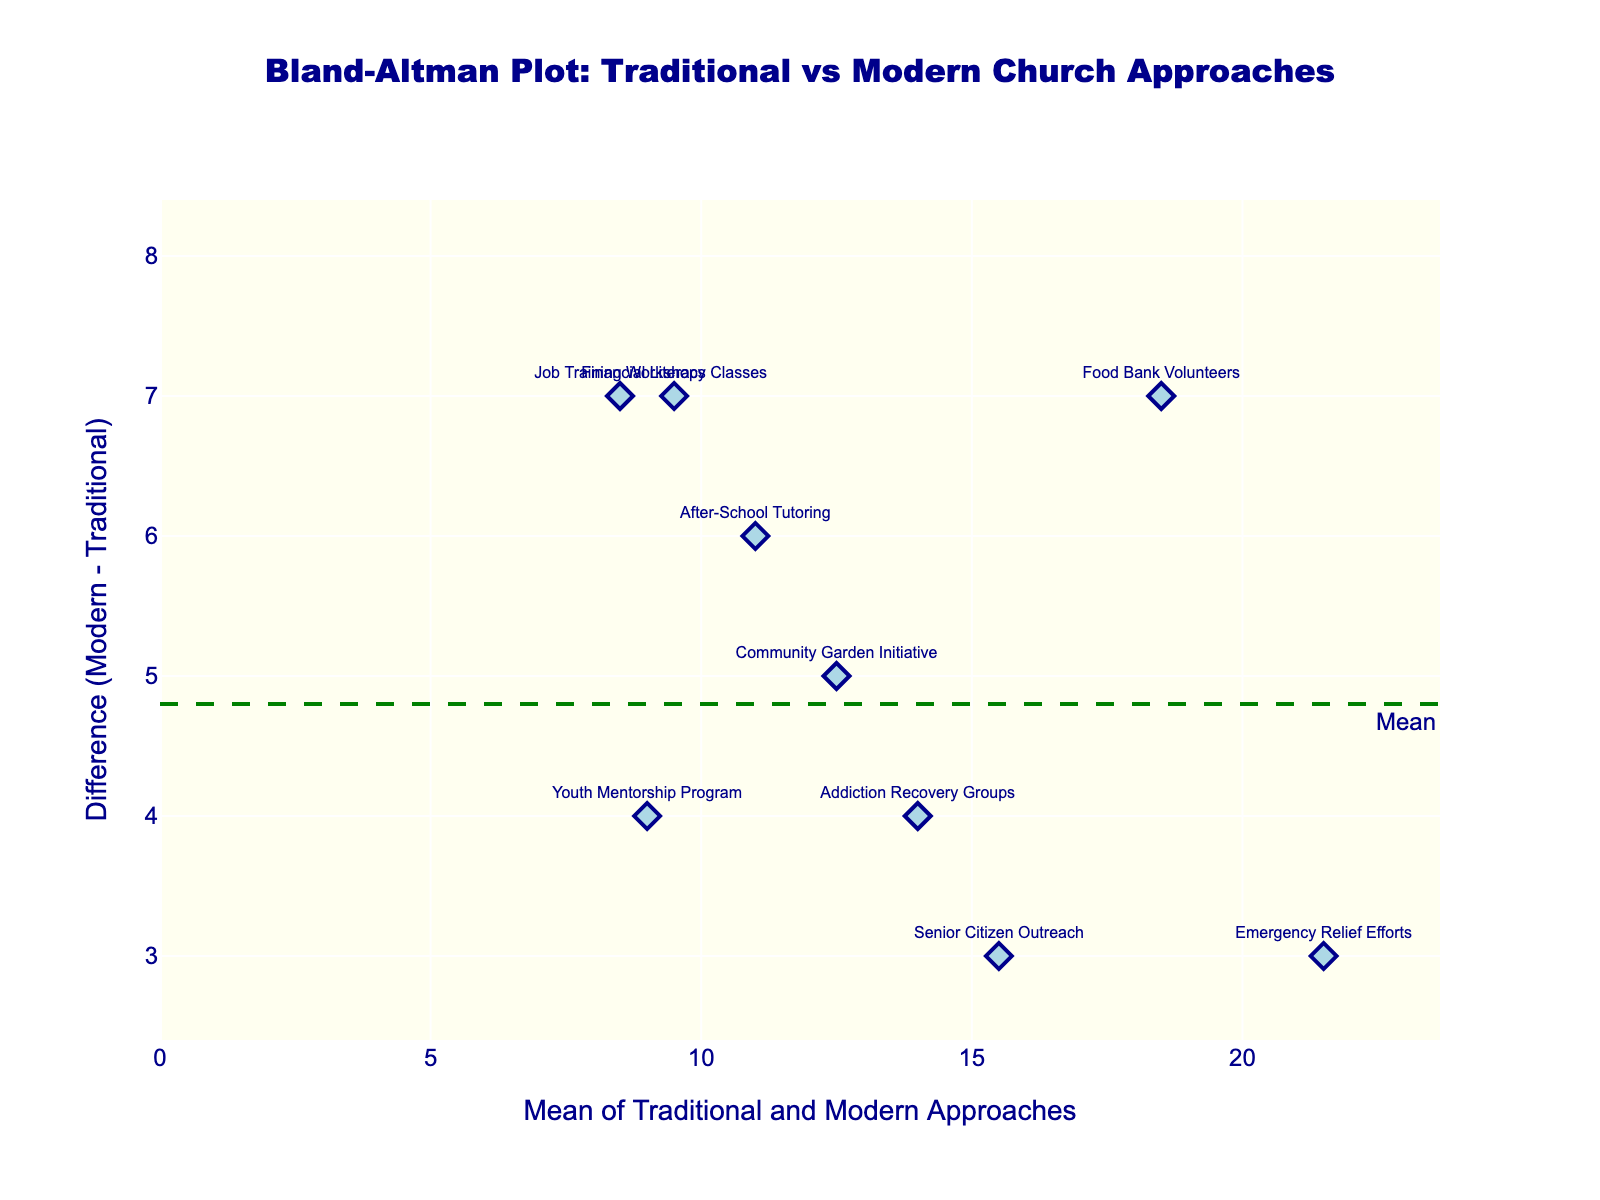Which method had the highest mean value of Traditional and Modern approaches? By looking at the plot and the x-axis (which shows the mean value), the data point with the highest position on the x-axis represents the method with the highest mean value. Here, "Emergency Relief Efforts" has the highest mean value.
Answer: Emergency Relief Efforts What is the mean difference between the Modern and Traditional approaches? The mean difference is represented by a horizontal dashed line on the plot. The green dashed line labeled "Mean" indicates this value.
Answer: About 4.5 What is the difference in impact on local poverty rates for Job Training Workshops between the Traditional and Modern approaches? Locate the "Job Training Workshops" data point on the plot by its label. The y-axis value for this point represents the difference between the Modern and Traditional approaches.
Answer: 7 Which method had the smallest impact difference between the Modern and Traditional approaches? The smallest impact difference corresponds to the data point closest to the x-axis (difference 0). "Homeless Shelter Support" is the closest to zero on the y-axis.
Answer: Homeless Shelter Support How does the variation of differences (spread) compare around the mean difference? To answer this, observe the distribution of points around the mean difference line. The red dashed lines labeled "-1.96 SD" and "+1.96 SD" show the limits. Most points are within these limits, indicating that the differences do not vary widely.
Answer: Within -1.96 SD and +1.96 SD What is the mean impact for Food Bank Volunteers combining Traditional and Modern approaches? Find "Food Bank Volunteers" on the plot and look at its x-axis value which shows the mean.
Answer: 18.5 Which outreach method shows the highest positive difference between Modern and Traditional approaches? The method with the highest positive difference is the topmost data point on the y-axis. "Financial Literacy Classes" is the highest.
Answer: Financial Literacy Classes What do the red dotted lines in the plot represent? Refer to the annotations in the plot. The red dotted lines represent the limits of agreement calculated as mean difference ± 1.96 SD, highlighting the variation range within which most differences lie.
Answer: Limits of agreement Is there any method where the Modern approach is less effective than the Traditional approach? Look for any points below the zero line on the y-axis. This will indicate a negative difference, showing Modern is less effective. No such points exist in this plot.
Answer: No What is the mean value of the Traditional and Modern approach for After-School Tutoring? Identify the "After-School Tutoring" label on the plot and check its x-axis position to find the mean value.
Answer: 11 